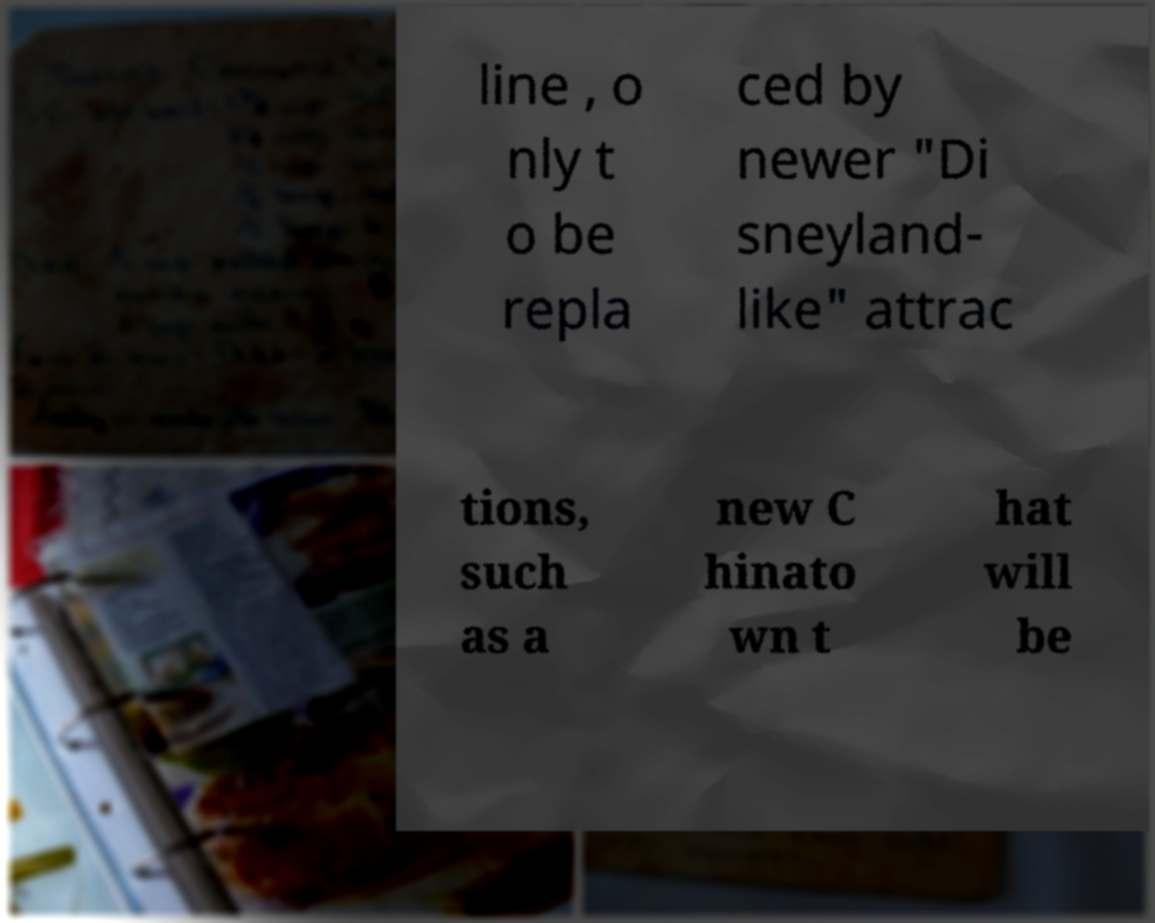Could you extract and type out the text from this image? line , o nly t o be repla ced by newer "Di sneyland- like" attrac tions, such as a new C hinato wn t hat will be 